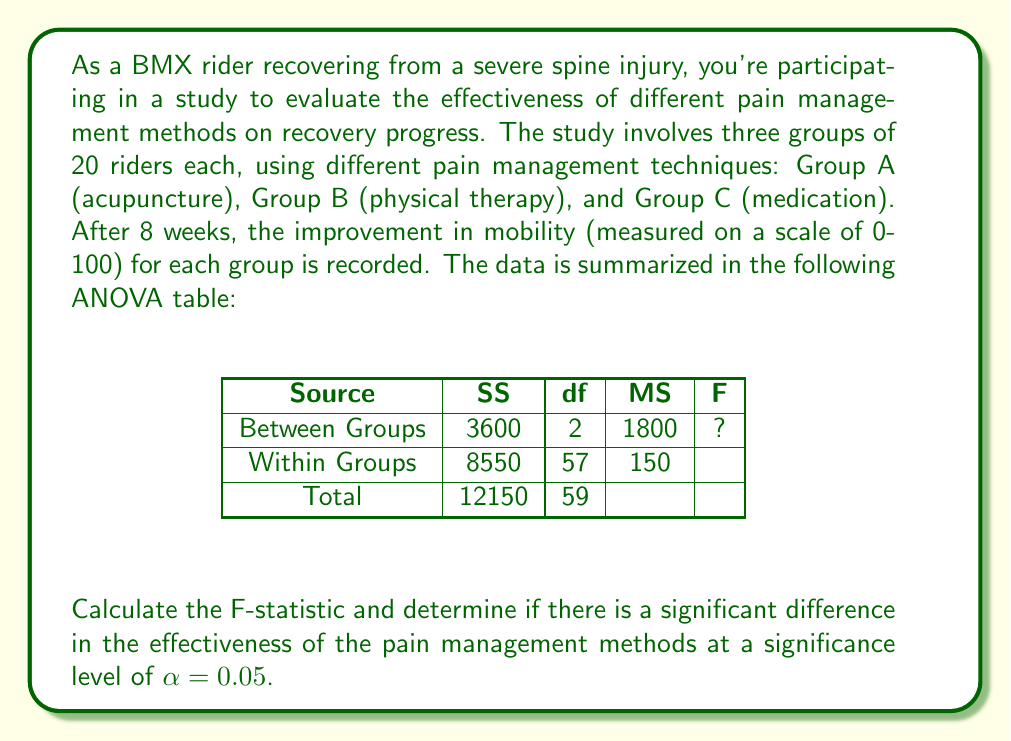Could you help me with this problem? Let's approach this step-by-step:

1) First, we need to calculate the F-statistic. The formula for the F-statistic is:

   $$F = \frac{MS_{between}}{MS_{within}}$$

2) From the ANOVA table, we can see:
   $MS_{between} = 1800$
   $MS_{within} = 150$

3) Plugging these values into the formula:

   $$F = \frac{1800}{150} = 12$$

4) Now that we have the F-statistic, we need to compare it to the critical F-value.

5) To find the critical F-value, we need:
   - Degrees of freedom for the numerator (df_between) = 2
   - Degrees of freedom for the denominator (df_within) = 57
   - Significance level $\alpha = 0.05$

6) Using an F-distribution table or calculator with these parameters, we find:
   $F_{critical} (2, 57, 0.05) \approx 3.16$

7) Decision rule: If $F_{calculated} > F_{critical}$, reject the null hypothesis.

8) In this case, $12 > 3.16$, so we reject the null hypothesis.

9) Interpretation: There is significant evidence to conclude that there is a difference in the effectiveness of the pain management methods at the 0.05 significance level.
Answer: $F = 12$; Significant difference exists (p < 0.05) 